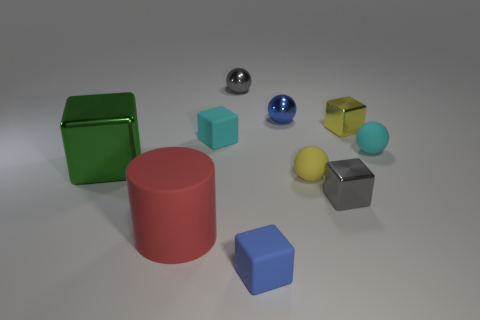Subtract all small cyan blocks. How many blocks are left? 4 Subtract all cyan blocks. How many blocks are left? 4 Subtract all gray spheres. Subtract all red blocks. How many spheres are left? 3 Subtract all cylinders. How many objects are left? 9 Add 2 big objects. How many big objects exist? 4 Subtract 0 green balls. How many objects are left? 10 Subtract all small cyan matte balls. Subtract all cyan rubber cubes. How many objects are left? 8 Add 1 small rubber things. How many small rubber things are left? 5 